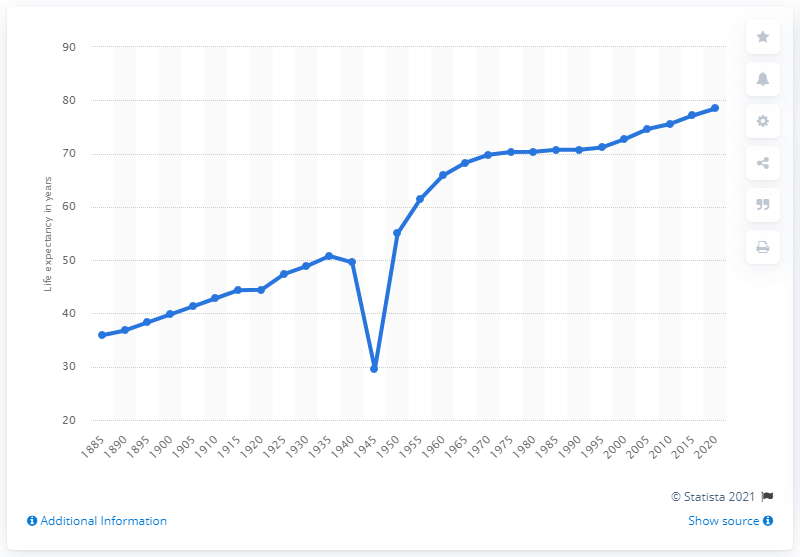Point out several critical features in this image. The life expectancy in Poland in 1885 was 35.9 years, according to historical records. 